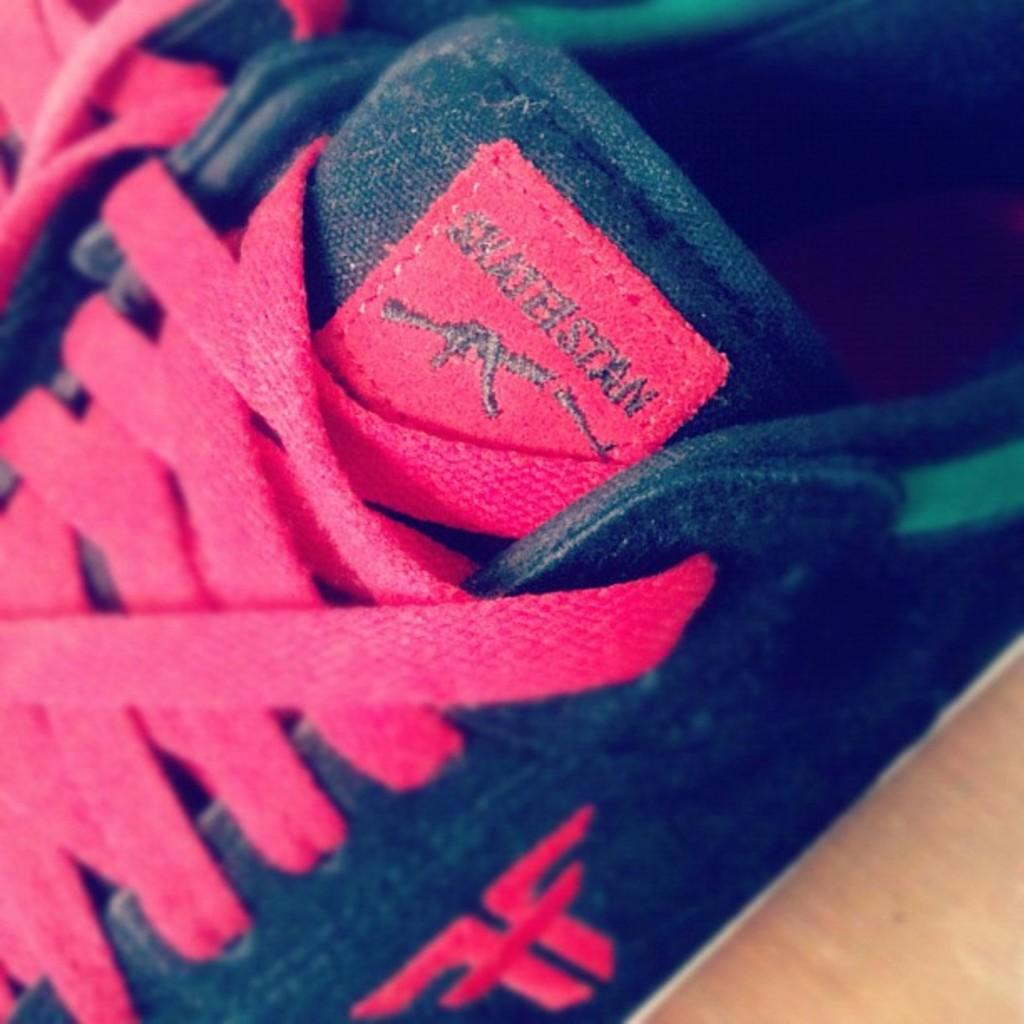What objects are in the image? There are shoes in the image. What type of surface are the shoes placed on? The shoes are on a wooden surface. How many sheep are in the image? There are no sheep or flock present in the image; it only features shoes on a wooden surface. What type of book is the person reading in the image? There is no person or book visible in the image; it only contains shoes on a wooden surface. 